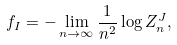<formula> <loc_0><loc_0><loc_500><loc_500>f _ { I } = - \lim _ { n \rightarrow \infty } \frac { 1 } { n ^ { 2 } } \log Z _ { n } ^ { J } ,</formula> 